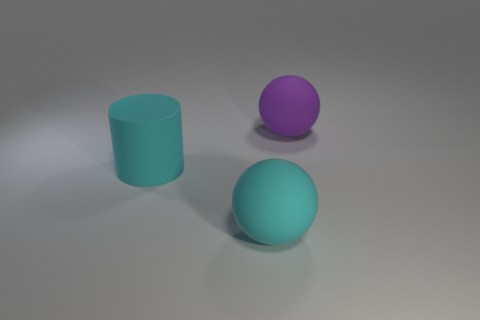There is a large thing that is in front of the large cylinder; is there a cyan object on the right side of it?
Give a very brief answer. No. What shape is the cyan thing in front of the matte cylinder?
Ensure brevity in your answer.  Sphere. There is a large thing that is the same color as the big matte cylinder; what is its material?
Provide a succinct answer. Rubber. There is a rubber sphere left of the matte thing behind the big cyan cylinder; what is its color?
Ensure brevity in your answer.  Cyan. Do the matte cylinder and the purple rubber sphere have the same size?
Ensure brevity in your answer.  Yes. What material is the big cyan thing that is the same shape as the purple object?
Offer a terse response. Rubber. How many things have the same size as the cyan rubber ball?
Ensure brevity in your answer.  2. There is a cylinder that is the same material as the big cyan sphere; what color is it?
Your answer should be compact. Cyan. Are there fewer small brown metal objects than purple objects?
Offer a terse response. Yes. How many cyan objects are cylinders or matte spheres?
Your answer should be very brief. 2. 